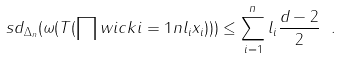Convert formula to latex. <formula><loc_0><loc_0><loc_500><loc_500>\ s d _ { \Delta _ { n } } ( \omega ( T ( \prod w i c k { i = 1 } { n } { l _ { i } } { x _ { i } } ) ) ) \leq \sum _ { i = 1 } ^ { n } l _ { i } \frac { d - 2 } { 2 } \ .</formula> 